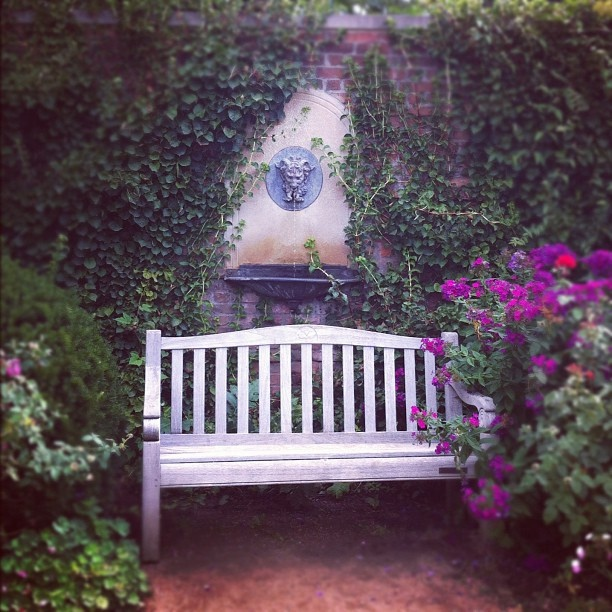Describe the objects in this image and their specific colors. I can see a bench in black, lavender, gray, and darkgray tones in this image. 